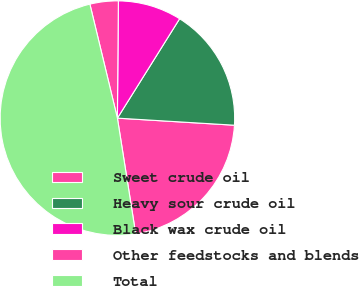Convert chart. <chart><loc_0><loc_0><loc_500><loc_500><pie_chart><fcel>Sweet crude oil<fcel>Heavy sour crude oil<fcel>Black wax crude oil<fcel>Other feedstocks and blends<fcel>Total<nl><fcel>21.54%<fcel>17.06%<fcel>8.77%<fcel>3.9%<fcel>48.73%<nl></chart> 